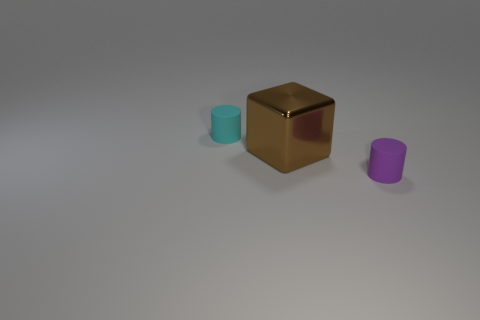There is a cube; is its color the same as the tiny cylinder that is to the right of the cyan matte object? No, the color of the cube is not the same as that of the tiny cylinder to the right of the cyan object. The cube has a golden color with reflective properties, while the cylinder appears to be purple with a matte finish. They are distinctly different in color and texture. 